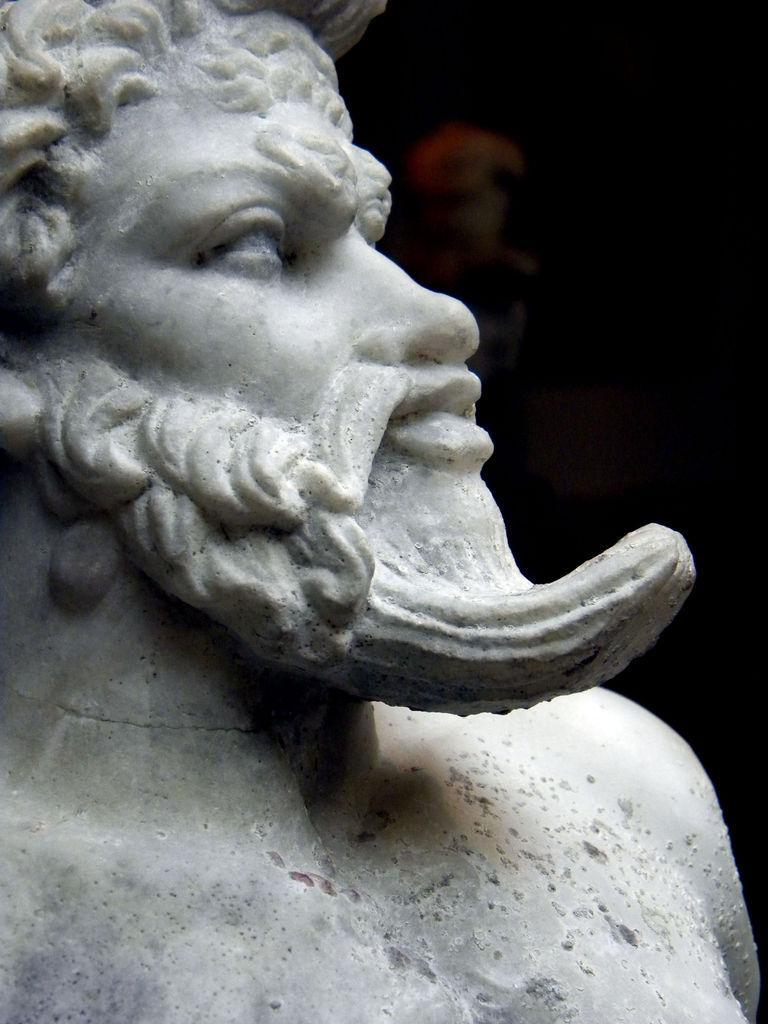In one or two sentences, can you explain what this image depicts? In the image we can see there is a statue of a person. 